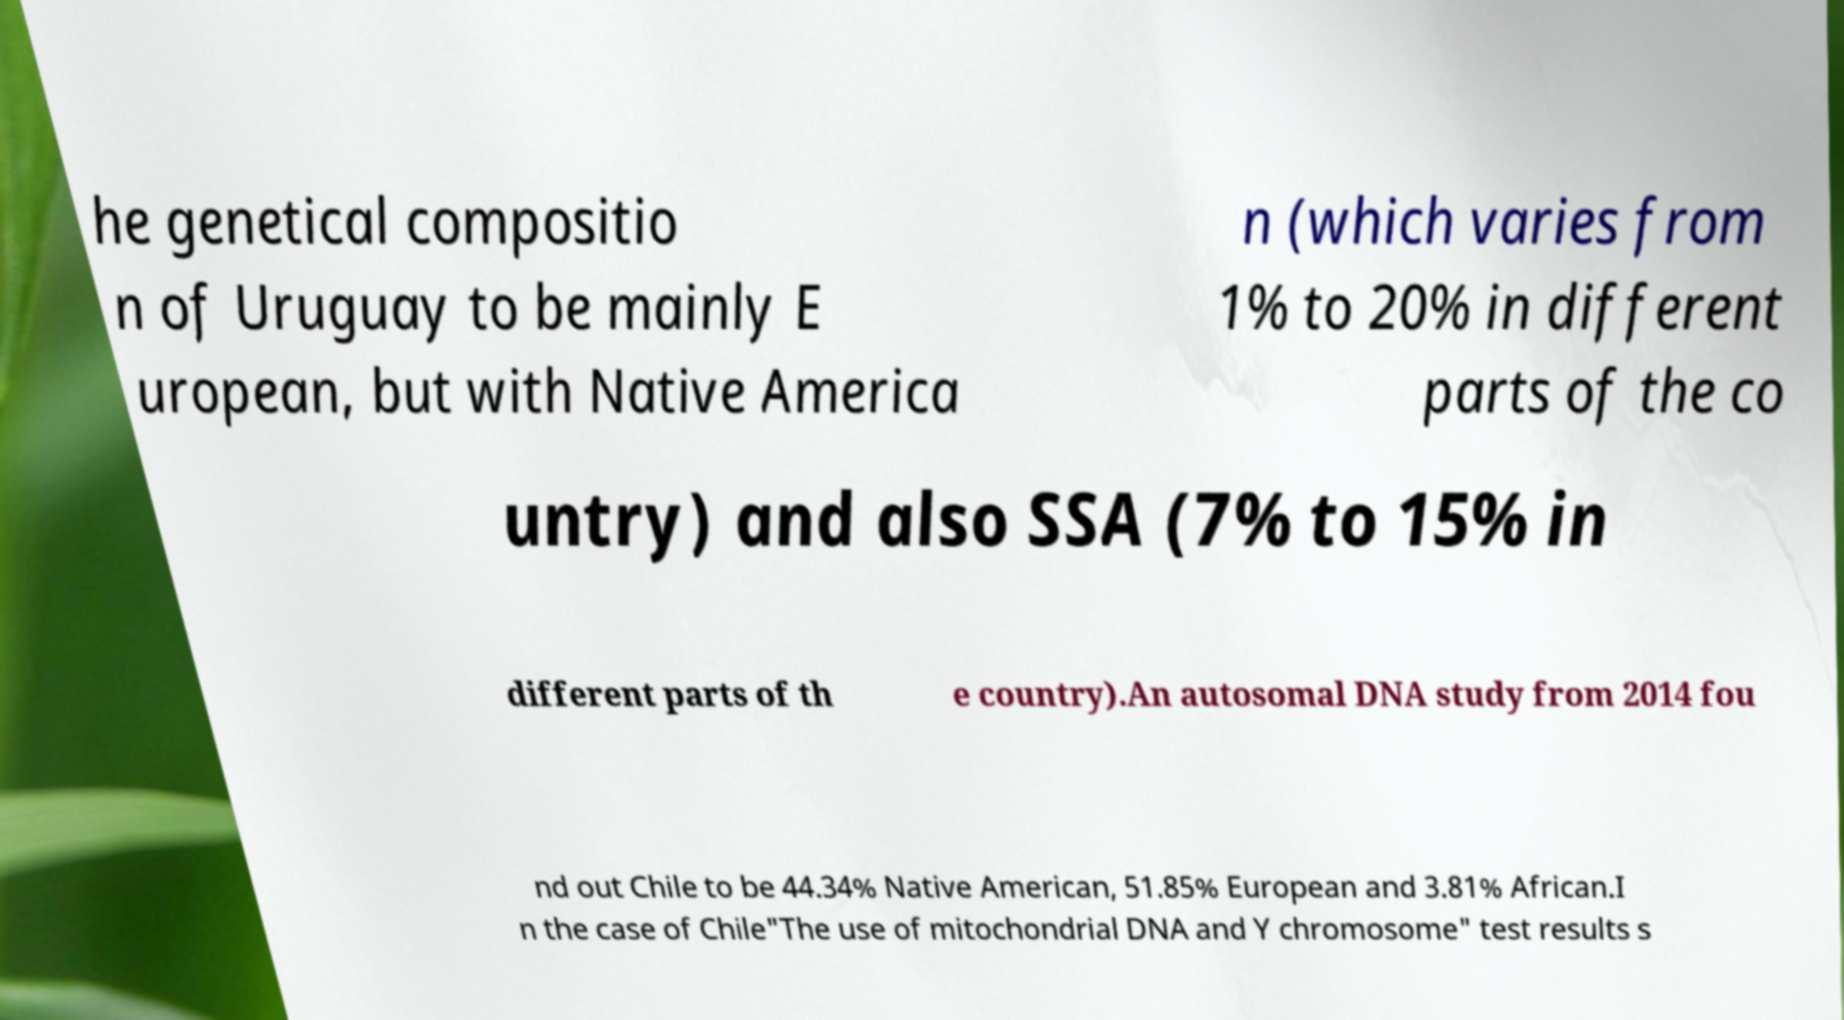For documentation purposes, I need the text within this image transcribed. Could you provide that? he genetical compositio n of Uruguay to be mainly E uropean, but with Native America n (which varies from 1% to 20% in different parts of the co untry) and also SSA (7% to 15% in different parts of th e country).An autosomal DNA study from 2014 fou nd out Chile to be 44.34% Native American, 51.85% European and 3.81% African.I n the case of Chile"The use of mitochondrial DNA and Y chromosome" test results s 